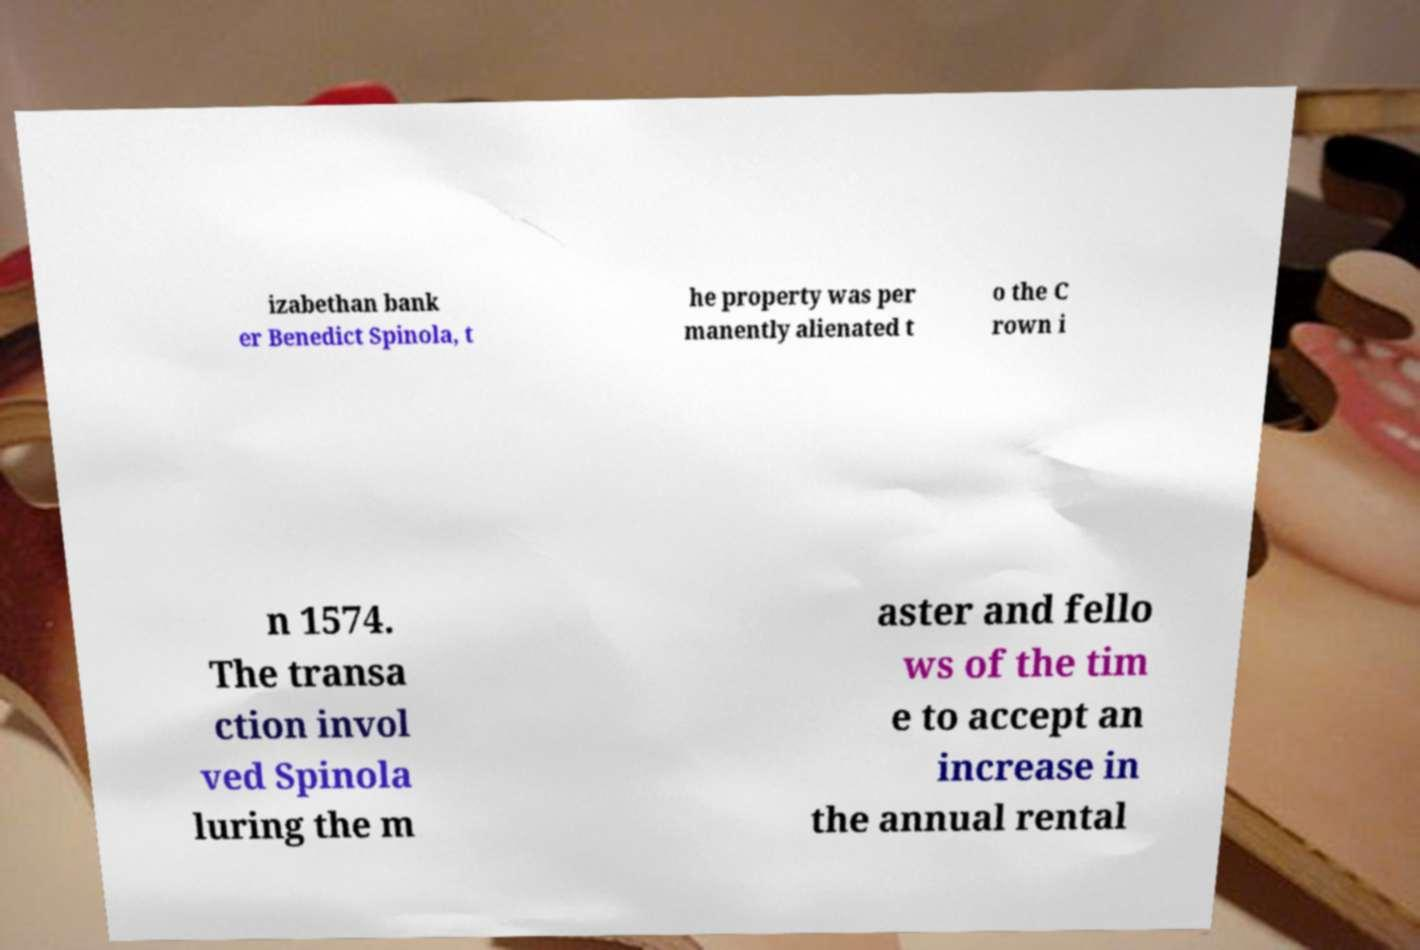Can you read and provide the text displayed in the image?This photo seems to have some interesting text. Can you extract and type it out for me? izabethan bank er Benedict Spinola, t he property was per manently alienated t o the C rown i n 1574. The transa ction invol ved Spinola luring the m aster and fello ws of the tim e to accept an increase in the annual rental 